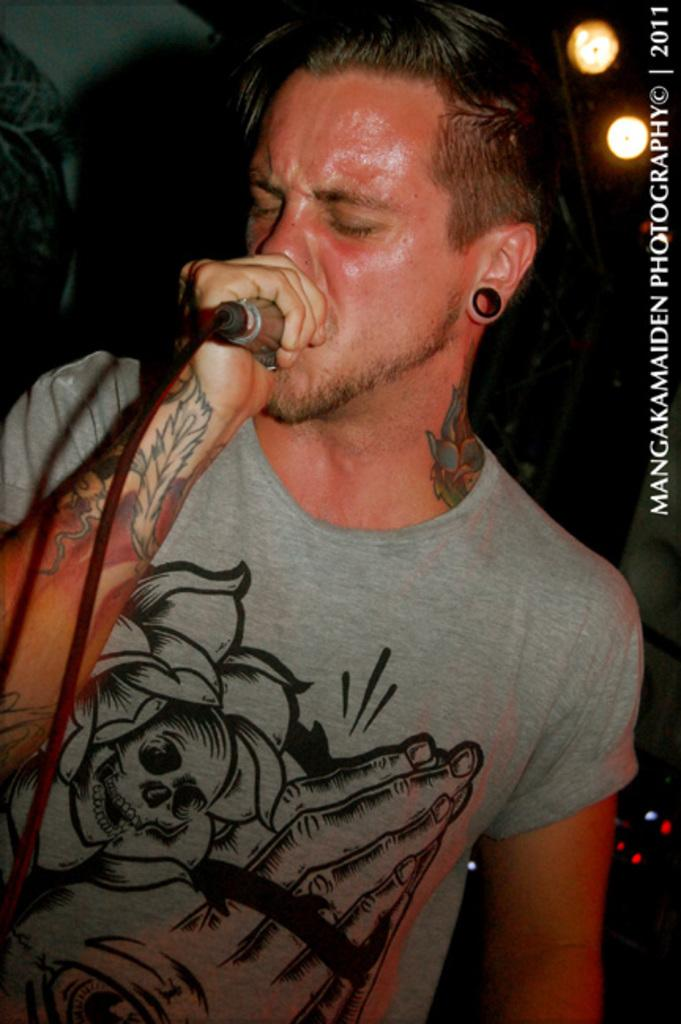Who is the main subject in the image? There is a man in the image. What is the man holding in the image? The man is holding a microphone. What is the man doing in the image? The man is singing. What can be seen in the background of the image? There is light visible in the background of the image. What type of celery is being used as a whistle by the man in the image? There is no celery or whistle present in the image; the man is holding a microphone and singing. 